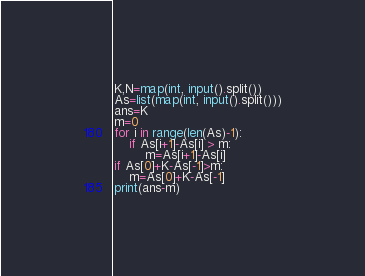<code> <loc_0><loc_0><loc_500><loc_500><_Python_>K,N=map(int, input().split())
As=list(map(int, input().split()))
ans=K
m=0
for i in range(len(As)-1):
    if As[i+1]-As[i] > m:
        m=As[i+1]-As[i]
if As[0]+K-As[-1]>m:
    m=As[0]+K-As[-1]
print(ans-m)</code> 